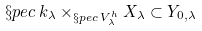<formula> <loc_0><loc_0><loc_500><loc_500>\S p e c \, k _ { \lambda } \times _ { \S p e c \, V ^ { h } _ { \lambda } } X _ { \lambda } \subset Y _ { 0 , \lambda }</formula> 